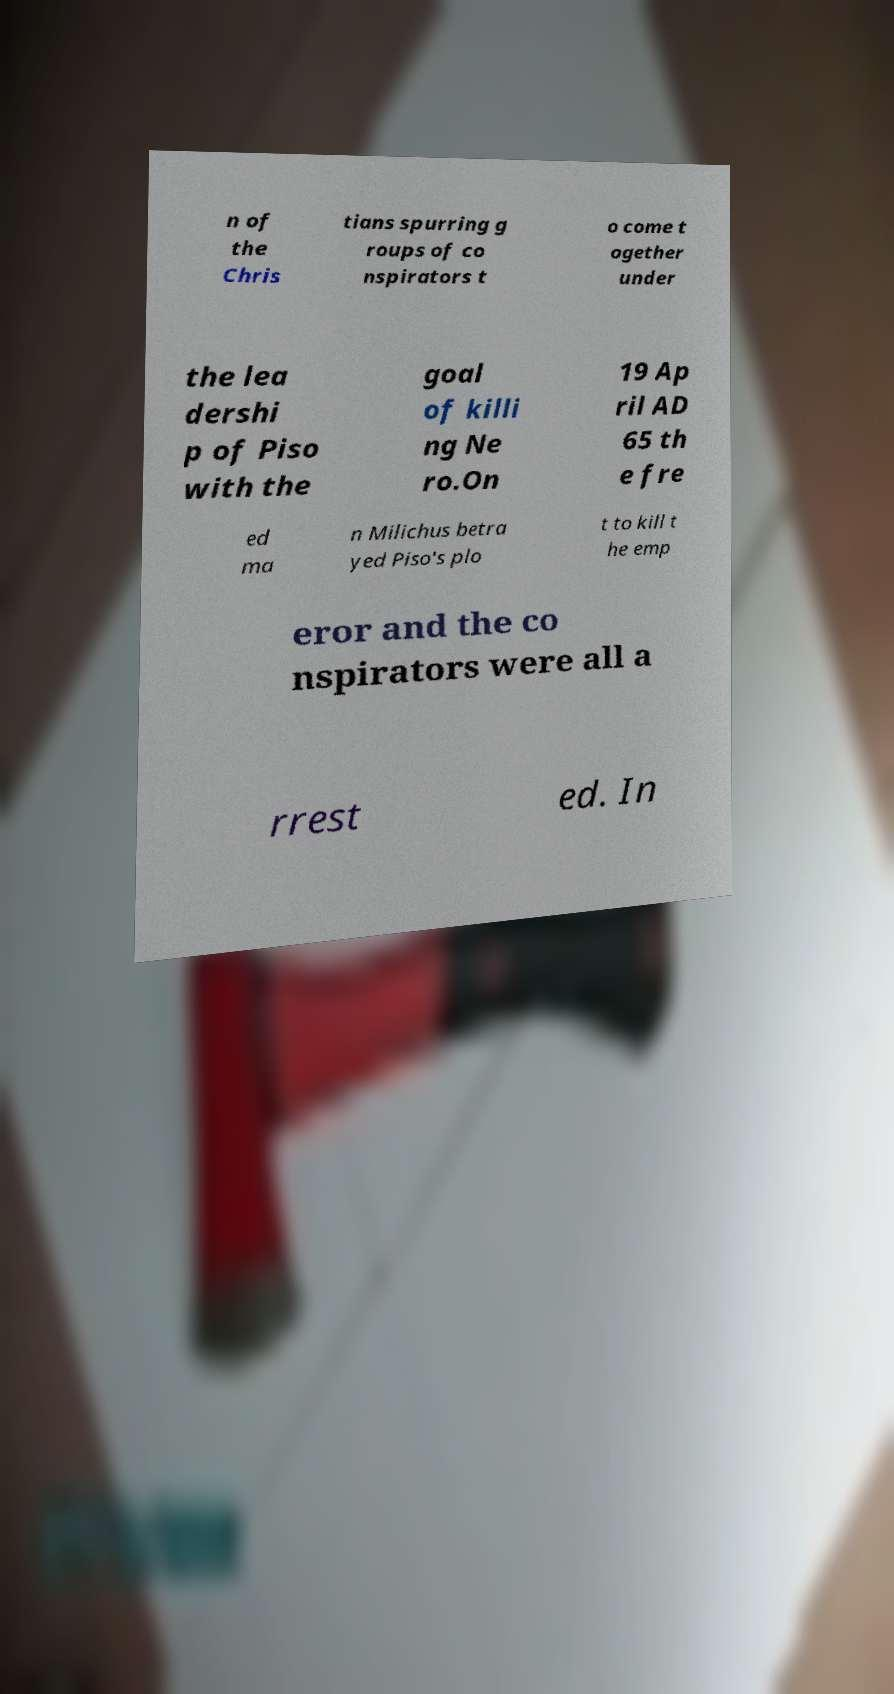Can you read and provide the text displayed in the image?This photo seems to have some interesting text. Can you extract and type it out for me? n of the Chris tians spurring g roups of co nspirators t o come t ogether under the lea dershi p of Piso with the goal of killi ng Ne ro.On 19 Ap ril AD 65 th e fre ed ma n Milichus betra yed Piso's plo t to kill t he emp eror and the co nspirators were all a rrest ed. In 